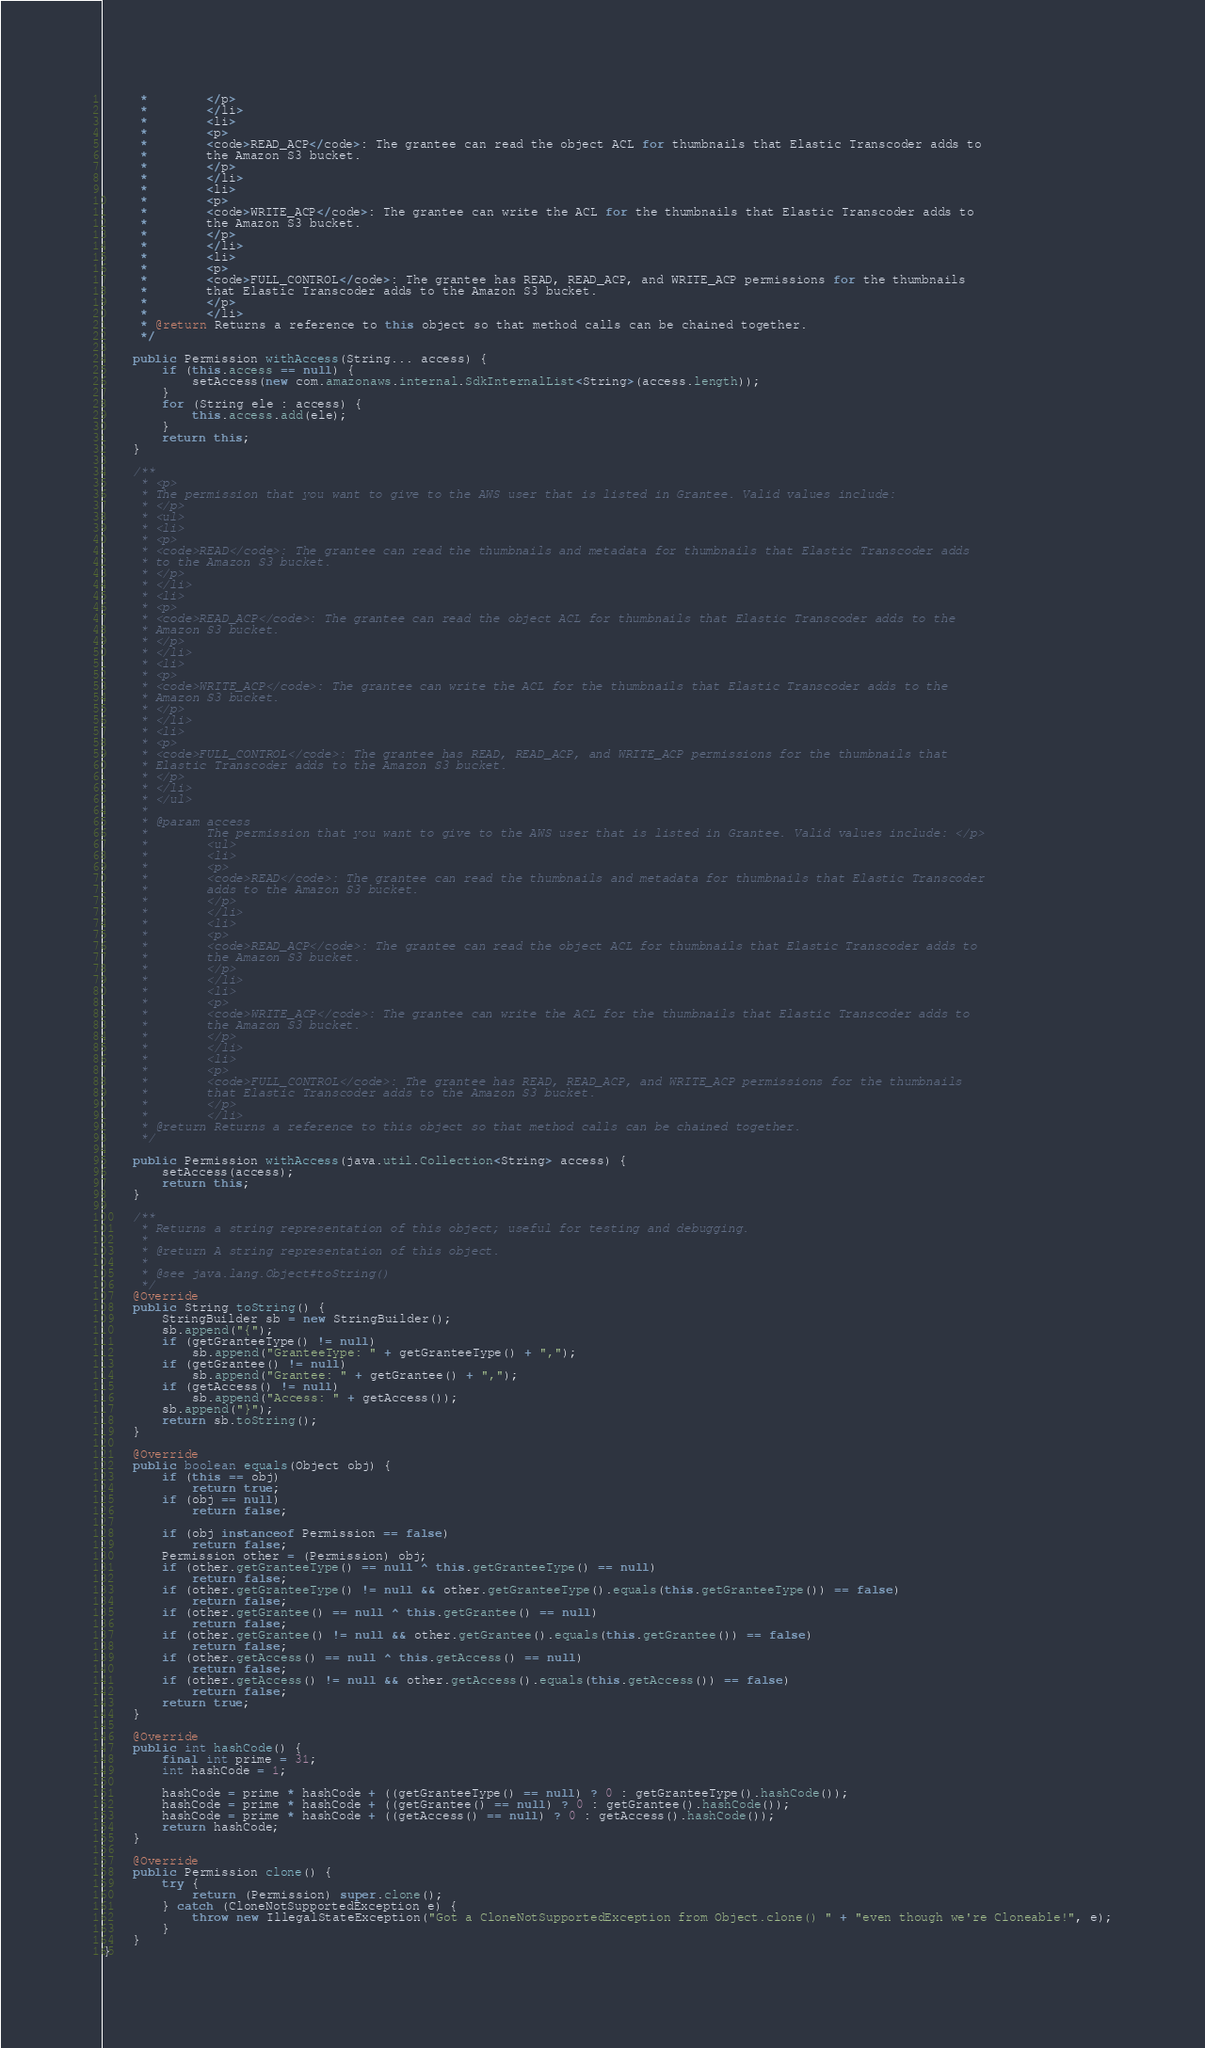Convert code to text. <code><loc_0><loc_0><loc_500><loc_500><_Java_>     *        </p>
     *        </li>
     *        <li>
     *        <p>
     *        <code>READ_ACP</code>: The grantee can read the object ACL for thumbnails that Elastic Transcoder adds to
     *        the Amazon S3 bucket.
     *        </p>
     *        </li>
     *        <li>
     *        <p>
     *        <code>WRITE_ACP</code>: The grantee can write the ACL for the thumbnails that Elastic Transcoder adds to
     *        the Amazon S3 bucket.
     *        </p>
     *        </li>
     *        <li>
     *        <p>
     *        <code>FULL_CONTROL</code>: The grantee has READ, READ_ACP, and WRITE_ACP permissions for the thumbnails
     *        that Elastic Transcoder adds to the Amazon S3 bucket.
     *        </p>
     *        </li>
     * @return Returns a reference to this object so that method calls can be chained together.
     */

    public Permission withAccess(String... access) {
        if (this.access == null) {
            setAccess(new com.amazonaws.internal.SdkInternalList<String>(access.length));
        }
        for (String ele : access) {
            this.access.add(ele);
        }
        return this;
    }

    /**
     * <p>
     * The permission that you want to give to the AWS user that is listed in Grantee. Valid values include:
     * </p>
     * <ul>
     * <li>
     * <p>
     * <code>READ</code>: The grantee can read the thumbnails and metadata for thumbnails that Elastic Transcoder adds
     * to the Amazon S3 bucket.
     * </p>
     * </li>
     * <li>
     * <p>
     * <code>READ_ACP</code>: The grantee can read the object ACL for thumbnails that Elastic Transcoder adds to the
     * Amazon S3 bucket.
     * </p>
     * </li>
     * <li>
     * <p>
     * <code>WRITE_ACP</code>: The grantee can write the ACL for the thumbnails that Elastic Transcoder adds to the
     * Amazon S3 bucket.
     * </p>
     * </li>
     * <li>
     * <p>
     * <code>FULL_CONTROL</code>: The grantee has READ, READ_ACP, and WRITE_ACP permissions for the thumbnails that
     * Elastic Transcoder adds to the Amazon S3 bucket.
     * </p>
     * </li>
     * </ul>
     * 
     * @param access
     *        The permission that you want to give to the AWS user that is listed in Grantee. Valid values include: </p>
     *        <ul>
     *        <li>
     *        <p>
     *        <code>READ</code>: The grantee can read the thumbnails and metadata for thumbnails that Elastic Transcoder
     *        adds to the Amazon S3 bucket.
     *        </p>
     *        </li>
     *        <li>
     *        <p>
     *        <code>READ_ACP</code>: The grantee can read the object ACL for thumbnails that Elastic Transcoder adds to
     *        the Amazon S3 bucket.
     *        </p>
     *        </li>
     *        <li>
     *        <p>
     *        <code>WRITE_ACP</code>: The grantee can write the ACL for the thumbnails that Elastic Transcoder adds to
     *        the Amazon S3 bucket.
     *        </p>
     *        </li>
     *        <li>
     *        <p>
     *        <code>FULL_CONTROL</code>: The grantee has READ, READ_ACP, and WRITE_ACP permissions for the thumbnails
     *        that Elastic Transcoder adds to the Amazon S3 bucket.
     *        </p>
     *        </li>
     * @return Returns a reference to this object so that method calls can be chained together.
     */

    public Permission withAccess(java.util.Collection<String> access) {
        setAccess(access);
        return this;
    }

    /**
     * Returns a string representation of this object; useful for testing and debugging.
     *
     * @return A string representation of this object.
     *
     * @see java.lang.Object#toString()
     */
    @Override
    public String toString() {
        StringBuilder sb = new StringBuilder();
        sb.append("{");
        if (getGranteeType() != null)
            sb.append("GranteeType: " + getGranteeType() + ",");
        if (getGrantee() != null)
            sb.append("Grantee: " + getGrantee() + ",");
        if (getAccess() != null)
            sb.append("Access: " + getAccess());
        sb.append("}");
        return sb.toString();
    }

    @Override
    public boolean equals(Object obj) {
        if (this == obj)
            return true;
        if (obj == null)
            return false;

        if (obj instanceof Permission == false)
            return false;
        Permission other = (Permission) obj;
        if (other.getGranteeType() == null ^ this.getGranteeType() == null)
            return false;
        if (other.getGranteeType() != null && other.getGranteeType().equals(this.getGranteeType()) == false)
            return false;
        if (other.getGrantee() == null ^ this.getGrantee() == null)
            return false;
        if (other.getGrantee() != null && other.getGrantee().equals(this.getGrantee()) == false)
            return false;
        if (other.getAccess() == null ^ this.getAccess() == null)
            return false;
        if (other.getAccess() != null && other.getAccess().equals(this.getAccess()) == false)
            return false;
        return true;
    }

    @Override
    public int hashCode() {
        final int prime = 31;
        int hashCode = 1;

        hashCode = prime * hashCode + ((getGranteeType() == null) ? 0 : getGranteeType().hashCode());
        hashCode = prime * hashCode + ((getGrantee() == null) ? 0 : getGrantee().hashCode());
        hashCode = prime * hashCode + ((getAccess() == null) ? 0 : getAccess().hashCode());
        return hashCode;
    }

    @Override
    public Permission clone() {
        try {
            return (Permission) super.clone();
        } catch (CloneNotSupportedException e) {
            throw new IllegalStateException("Got a CloneNotSupportedException from Object.clone() " + "even though we're Cloneable!", e);
        }
    }
}
</code> 